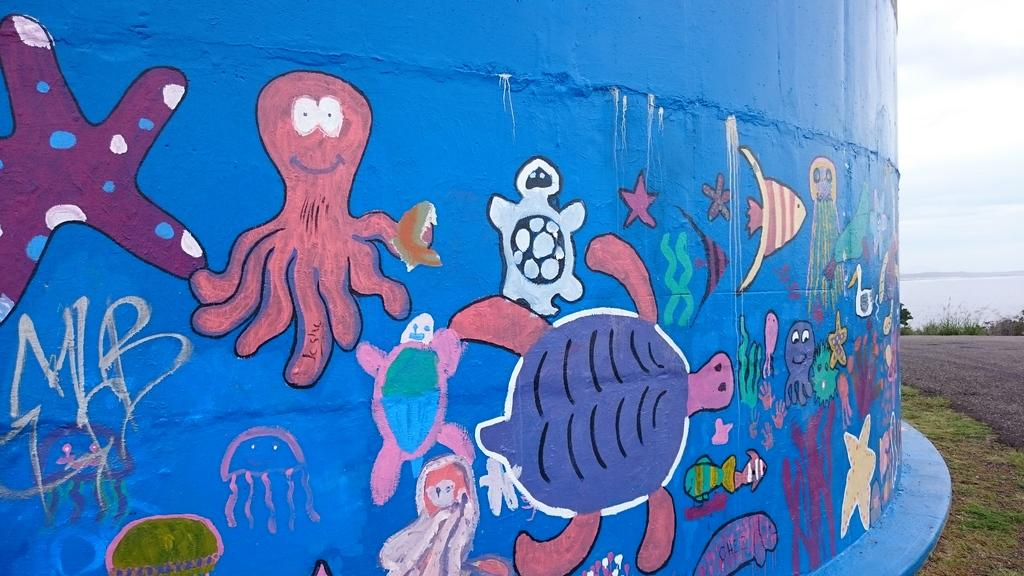What color is the wall in the image? The wall in the image is blue. What is on the wall in the image? There is some art on the wall in the image. What can be seen in the background of the image? Water and the sky are visible in the image. What type of vegetation is present in the image? Plants and grass are present in the image. Where is the scarecrow standing in the image? There is no scarecrow present in the image. How many giants can be seen in the image? There are no giants present in the image. 